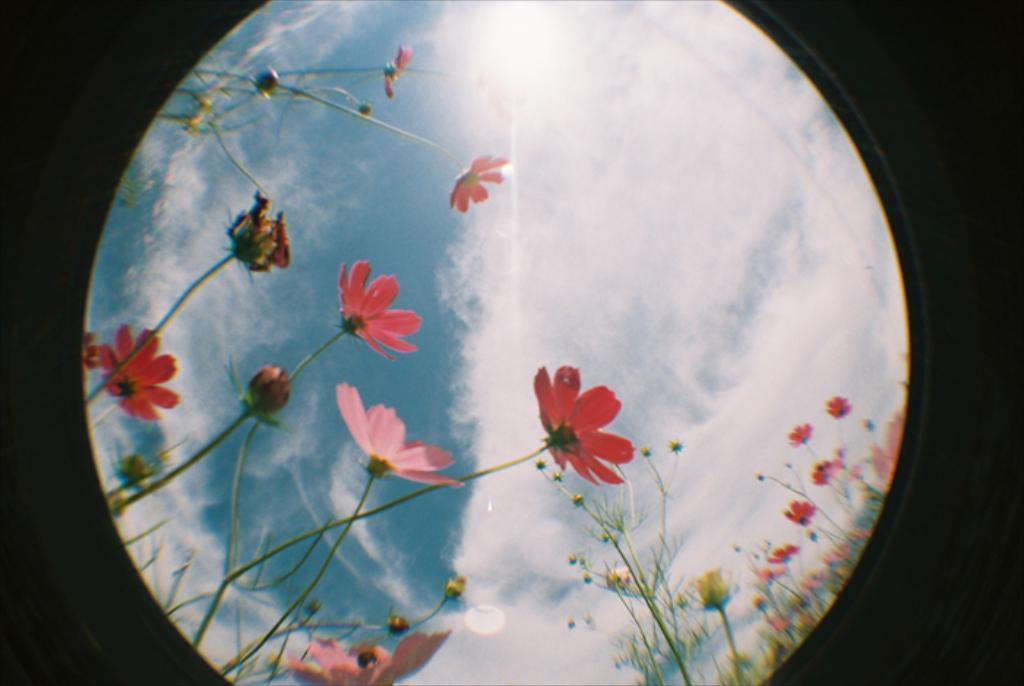Can you describe this image briefly? In this picture we can see few flowers, clouds, plants and dark background. 